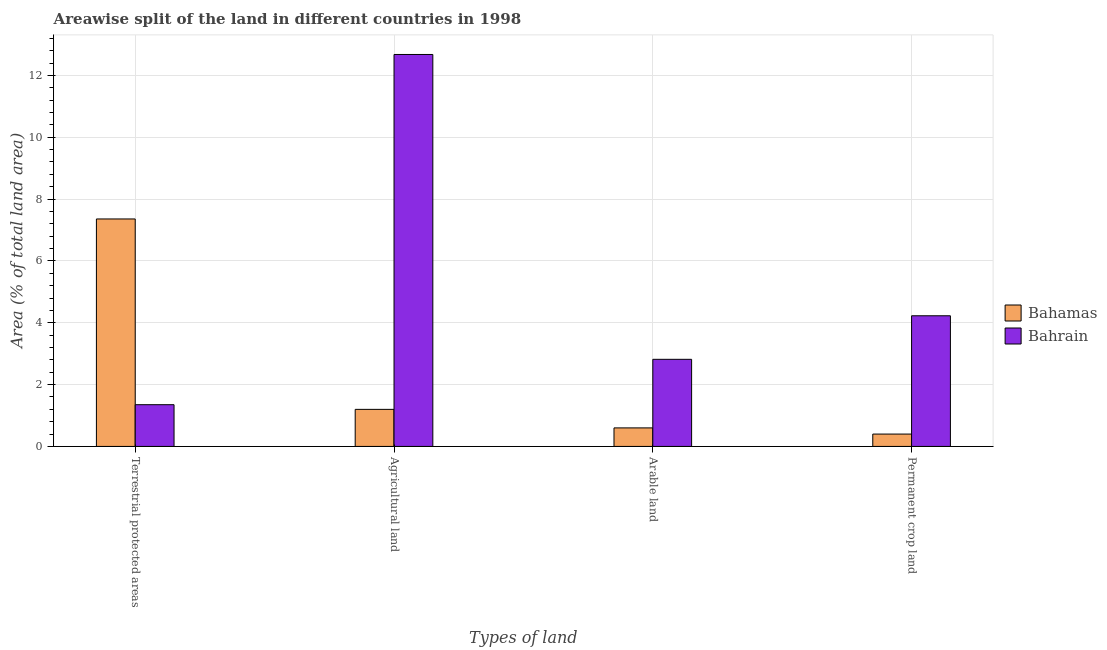Are the number of bars per tick equal to the number of legend labels?
Keep it short and to the point. Yes. Are the number of bars on each tick of the X-axis equal?
Your answer should be compact. Yes. How many bars are there on the 3rd tick from the left?
Your answer should be very brief. 2. How many bars are there on the 2nd tick from the right?
Your answer should be very brief. 2. What is the label of the 2nd group of bars from the left?
Provide a succinct answer. Agricultural land. What is the percentage of area under permanent crop land in Bahrain?
Keep it short and to the point. 4.23. Across all countries, what is the maximum percentage of area under agricultural land?
Your answer should be compact. 12.68. Across all countries, what is the minimum percentage of land under terrestrial protection?
Offer a very short reply. 1.35. In which country was the percentage of land under terrestrial protection maximum?
Provide a succinct answer. Bahamas. In which country was the percentage of land under terrestrial protection minimum?
Make the answer very short. Bahrain. What is the total percentage of area under agricultural land in the graph?
Provide a short and direct response. 13.87. What is the difference between the percentage of area under agricultural land in Bahrain and that in Bahamas?
Ensure brevity in your answer.  11.48. What is the difference between the percentage of land under terrestrial protection in Bahamas and the percentage of area under agricultural land in Bahrain?
Give a very brief answer. -5.32. What is the average percentage of land under terrestrial protection per country?
Provide a succinct answer. 4.35. What is the difference between the percentage of area under permanent crop land and percentage of area under agricultural land in Bahrain?
Give a very brief answer. -8.45. What is the ratio of the percentage of land under terrestrial protection in Bahrain to that in Bahamas?
Ensure brevity in your answer.  0.18. Is the difference between the percentage of land under terrestrial protection in Bahamas and Bahrain greater than the difference between the percentage of area under arable land in Bahamas and Bahrain?
Your response must be concise. Yes. What is the difference between the highest and the second highest percentage of area under permanent crop land?
Provide a short and direct response. 3.83. What is the difference between the highest and the lowest percentage of land under terrestrial protection?
Make the answer very short. 6.01. Is the sum of the percentage of land under terrestrial protection in Bahrain and Bahamas greater than the maximum percentage of area under agricultural land across all countries?
Provide a succinct answer. No. Is it the case that in every country, the sum of the percentage of area under arable land and percentage of area under permanent crop land is greater than the sum of percentage of land under terrestrial protection and percentage of area under agricultural land?
Offer a terse response. No. What does the 1st bar from the left in Terrestrial protected areas represents?
Your answer should be very brief. Bahamas. What does the 2nd bar from the right in Permanent crop land represents?
Your response must be concise. Bahamas. Is it the case that in every country, the sum of the percentage of land under terrestrial protection and percentage of area under agricultural land is greater than the percentage of area under arable land?
Provide a short and direct response. Yes. How many bars are there?
Give a very brief answer. 8. What is the difference between two consecutive major ticks on the Y-axis?
Offer a terse response. 2. Are the values on the major ticks of Y-axis written in scientific E-notation?
Keep it short and to the point. No. Does the graph contain any zero values?
Your answer should be compact. No. Does the graph contain grids?
Provide a succinct answer. Yes. How many legend labels are there?
Provide a succinct answer. 2. How are the legend labels stacked?
Your answer should be very brief. Vertical. What is the title of the graph?
Your answer should be very brief. Areawise split of the land in different countries in 1998. Does "Samoa" appear as one of the legend labels in the graph?
Provide a succinct answer. No. What is the label or title of the X-axis?
Your answer should be compact. Types of land. What is the label or title of the Y-axis?
Make the answer very short. Area (% of total land area). What is the Area (% of total land area) in Bahamas in Terrestrial protected areas?
Keep it short and to the point. 7.36. What is the Area (% of total land area) of Bahrain in Terrestrial protected areas?
Make the answer very short. 1.35. What is the Area (% of total land area) of Bahamas in Agricultural land?
Provide a succinct answer. 1.2. What is the Area (% of total land area) of Bahrain in Agricultural land?
Your answer should be compact. 12.68. What is the Area (% of total land area) in Bahamas in Arable land?
Offer a terse response. 0.6. What is the Area (% of total land area) in Bahrain in Arable land?
Provide a short and direct response. 2.82. What is the Area (% of total land area) of Bahamas in Permanent crop land?
Your answer should be compact. 0.4. What is the Area (% of total land area) of Bahrain in Permanent crop land?
Make the answer very short. 4.23. Across all Types of land, what is the maximum Area (% of total land area) in Bahamas?
Offer a terse response. 7.36. Across all Types of land, what is the maximum Area (% of total land area) of Bahrain?
Provide a short and direct response. 12.68. Across all Types of land, what is the minimum Area (% of total land area) of Bahamas?
Make the answer very short. 0.4. Across all Types of land, what is the minimum Area (% of total land area) of Bahrain?
Your response must be concise. 1.35. What is the total Area (% of total land area) of Bahamas in the graph?
Give a very brief answer. 9.55. What is the total Area (% of total land area) in Bahrain in the graph?
Make the answer very short. 21.07. What is the difference between the Area (% of total land area) of Bahamas in Terrestrial protected areas and that in Agricultural land?
Keep it short and to the point. 6.16. What is the difference between the Area (% of total land area) of Bahrain in Terrestrial protected areas and that in Agricultural land?
Give a very brief answer. -11.33. What is the difference between the Area (% of total land area) in Bahamas in Terrestrial protected areas and that in Arable land?
Ensure brevity in your answer.  6.76. What is the difference between the Area (% of total land area) in Bahrain in Terrestrial protected areas and that in Arable land?
Your answer should be very brief. -1.47. What is the difference between the Area (% of total land area) of Bahamas in Terrestrial protected areas and that in Permanent crop land?
Your answer should be compact. 6.96. What is the difference between the Area (% of total land area) of Bahrain in Terrestrial protected areas and that in Permanent crop land?
Ensure brevity in your answer.  -2.88. What is the difference between the Area (% of total land area) in Bahamas in Agricultural land and that in Arable land?
Your answer should be compact. 0.6. What is the difference between the Area (% of total land area) in Bahrain in Agricultural land and that in Arable land?
Ensure brevity in your answer.  9.86. What is the difference between the Area (% of total land area) of Bahamas in Agricultural land and that in Permanent crop land?
Give a very brief answer. 0.8. What is the difference between the Area (% of total land area) in Bahrain in Agricultural land and that in Permanent crop land?
Ensure brevity in your answer.  8.45. What is the difference between the Area (% of total land area) of Bahamas in Arable land and that in Permanent crop land?
Offer a very short reply. 0.2. What is the difference between the Area (% of total land area) in Bahrain in Arable land and that in Permanent crop land?
Make the answer very short. -1.41. What is the difference between the Area (% of total land area) in Bahamas in Terrestrial protected areas and the Area (% of total land area) in Bahrain in Agricultural land?
Keep it short and to the point. -5.32. What is the difference between the Area (% of total land area) of Bahamas in Terrestrial protected areas and the Area (% of total land area) of Bahrain in Arable land?
Give a very brief answer. 4.54. What is the difference between the Area (% of total land area) in Bahamas in Terrestrial protected areas and the Area (% of total land area) in Bahrain in Permanent crop land?
Your answer should be very brief. 3.13. What is the difference between the Area (% of total land area) of Bahamas in Agricultural land and the Area (% of total land area) of Bahrain in Arable land?
Give a very brief answer. -1.62. What is the difference between the Area (% of total land area) of Bahamas in Agricultural land and the Area (% of total land area) of Bahrain in Permanent crop land?
Offer a very short reply. -3.03. What is the difference between the Area (% of total land area) in Bahamas in Arable land and the Area (% of total land area) in Bahrain in Permanent crop land?
Provide a succinct answer. -3.63. What is the average Area (% of total land area) of Bahamas per Types of land?
Offer a terse response. 2.39. What is the average Area (% of total land area) in Bahrain per Types of land?
Provide a succinct answer. 5.27. What is the difference between the Area (% of total land area) in Bahamas and Area (% of total land area) in Bahrain in Terrestrial protected areas?
Your response must be concise. 6.01. What is the difference between the Area (% of total land area) of Bahamas and Area (% of total land area) of Bahrain in Agricultural land?
Ensure brevity in your answer.  -11.48. What is the difference between the Area (% of total land area) in Bahamas and Area (% of total land area) in Bahrain in Arable land?
Provide a short and direct response. -2.22. What is the difference between the Area (% of total land area) in Bahamas and Area (% of total land area) in Bahrain in Permanent crop land?
Ensure brevity in your answer.  -3.83. What is the ratio of the Area (% of total land area) of Bahamas in Terrestrial protected areas to that in Agricultural land?
Provide a succinct answer. 6.14. What is the ratio of the Area (% of total land area) in Bahrain in Terrestrial protected areas to that in Agricultural land?
Keep it short and to the point. 0.11. What is the ratio of the Area (% of total land area) of Bahamas in Terrestrial protected areas to that in Arable land?
Your answer should be compact. 12.27. What is the ratio of the Area (% of total land area) of Bahrain in Terrestrial protected areas to that in Arable land?
Ensure brevity in your answer.  0.48. What is the ratio of the Area (% of total land area) in Bahamas in Terrestrial protected areas to that in Permanent crop land?
Make the answer very short. 18.41. What is the ratio of the Area (% of total land area) in Bahrain in Terrestrial protected areas to that in Permanent crop land?
Provide a short and direct response. 0.32. What is the ratio of the Area (% of total land area) of Bahamas in Agricultural land to that in Arable land?
Offer a very short reply. 2. What is the ratio of the Area (% of total land area) in Bahrain in Agricultural land to that in Arable land?
Offer a terse response. 4.5. What is the ratio of the Area (% of total land area) of Bahrain in Arable land to that in Permanent crop land?
Offer a terse response. 0.67. What is the difference between the highest and the second highest Area (% of total land area) in Bahamas?
Offer a very short reply. 6.16. What is the difference between the highest and the second highest Area (% of total land area) of Bahrain?
Offer a terse response. 8.45. What is the difference between the highest and the lowest Area (% of total land area) in Bahamas?
Make the answer very short. 6.96. What is the difference between the highest and the lowest Area (% of total land area) of Bahrain?
Provide a short and direct response. 11.33. 